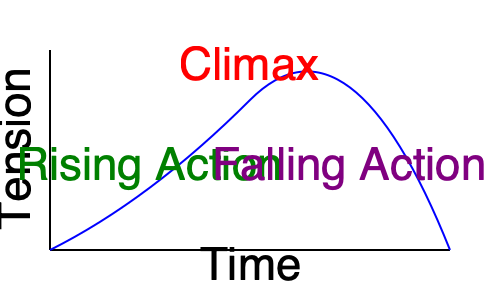In the given plot structure graph, which element typically occupies the largest portion of the story and gradually builds tension towards the climax? To answer this question, let's analyze the plot structure graph:

1. The graph shows the classic plot structure, with tension (y-axis) plotted against time (x-axis).

2. We can identify three main parts of the plot:
   a) Rising Action: The left side of the curve, gradually increasing in tension
   b) Climax: The peak of the curve, representing the highest point of tension
   c) Falling Action: The right side of the curve, where tension decreases

3. Looking at the graph, we can see that the Rising Action occupies the largest portion of the x-axis (time).

4. The Rising Action is where the main conflict develops, complications arise, and tension builds. This is typically the longest part of a story, as it sets up the characters, introduces obstacles, and creates suspense leading to the climax.

5. The Climax, while crucial, is usually a shorter, intense moment in the story.

6. The Falling Action, which follows the Climax, is typically shorter than the Rising Action as it resolves conflicts and leads to the conclusion.

Therefore, the element that typically occupies the largest portion of the story and gradually builds tension towards the climax is the Rising Action.
Answer: Rising Action 